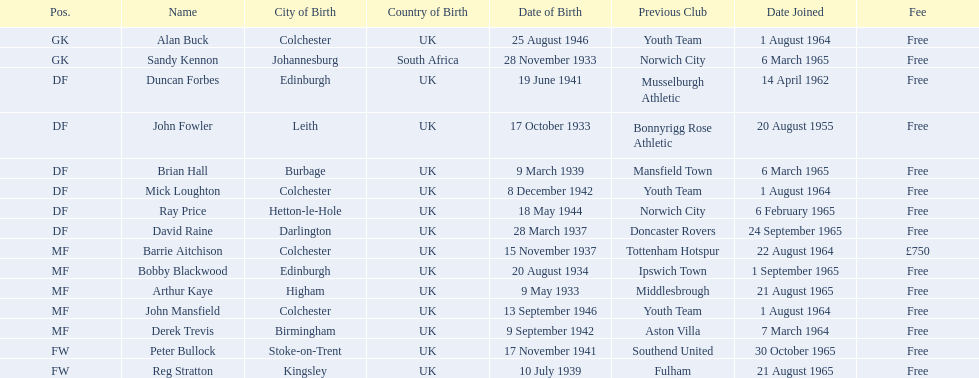When did each player join? 1 August 1964, 6 March 1965, 14 April 1962, 20 August 1955, 6 March 1965, 1 August 1964, 6 February 1965, 24 September 1965, 22 August 1964, 1 September 1965, 21 August 1965, 1 August 1964, 7 March 1964, 30 October 1965, 21 August 1965. And of those, which is the earliest join date? 20 August 1955. 